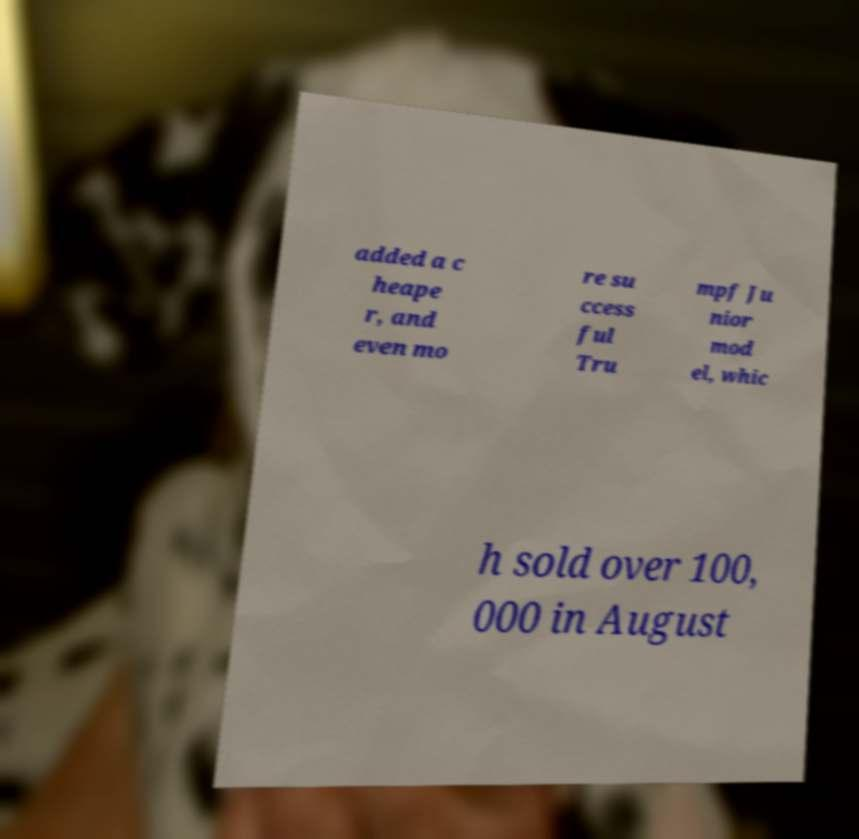Can you read and provide the text displayed in the image?This photo seems to have some interesting text. Can you extract and type it out for me? added a c heape r, and even mo re su ccess ful Tru mpf Ju nior mod el, whic h sold over 100, 000 in August 